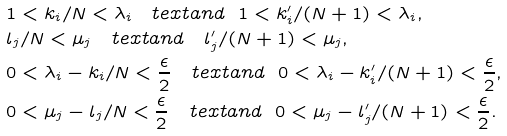Convert formula to latex. <formula><loc_0><loc_0><loc_500><loc_500>& 1 < k _ { i } / N < \lambda _ { i } \quad t e x t { a n d } \ \ 1 < k ^ { \prime } _ { i } / ( N + 1 ) < \lambda _ { i } , \\ & l _ { j } / N < \mu _ { j } \quad t e x t { a n d } \quad l ^ { \prime } _ { j } / ( N + 1 ) < \mu _ { j } , \\ & 0 < \lambda _ { i } - k _ { i } / N < \frac { \epsilon } { 2 } \quad t e x t { a n d } \ \ 0 < \lambda _ { i } - k ^ { \prime } _ { i } / ( N + 1 ) < \frac { \epsilon } { 2 } , \\ & 0 < \mu _ { j } - l _ { j } / N < \frac { \epsilon } { 2 } \ \ \ t e x t { a n d } \ \ 0 < \mu _ { j } - l ^ { \prime } _ { j } / ( N + 1 ) < \frac { \epsilon } { 2 } .</formula> 